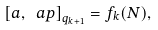Convert formula to latex. <formula><loc_0><loc_0><loc_500><loc_500>\left [ a , \ a p \right ] _ { q _ { k + 1 } } = f _ { k } ( N ) ,</formula> 